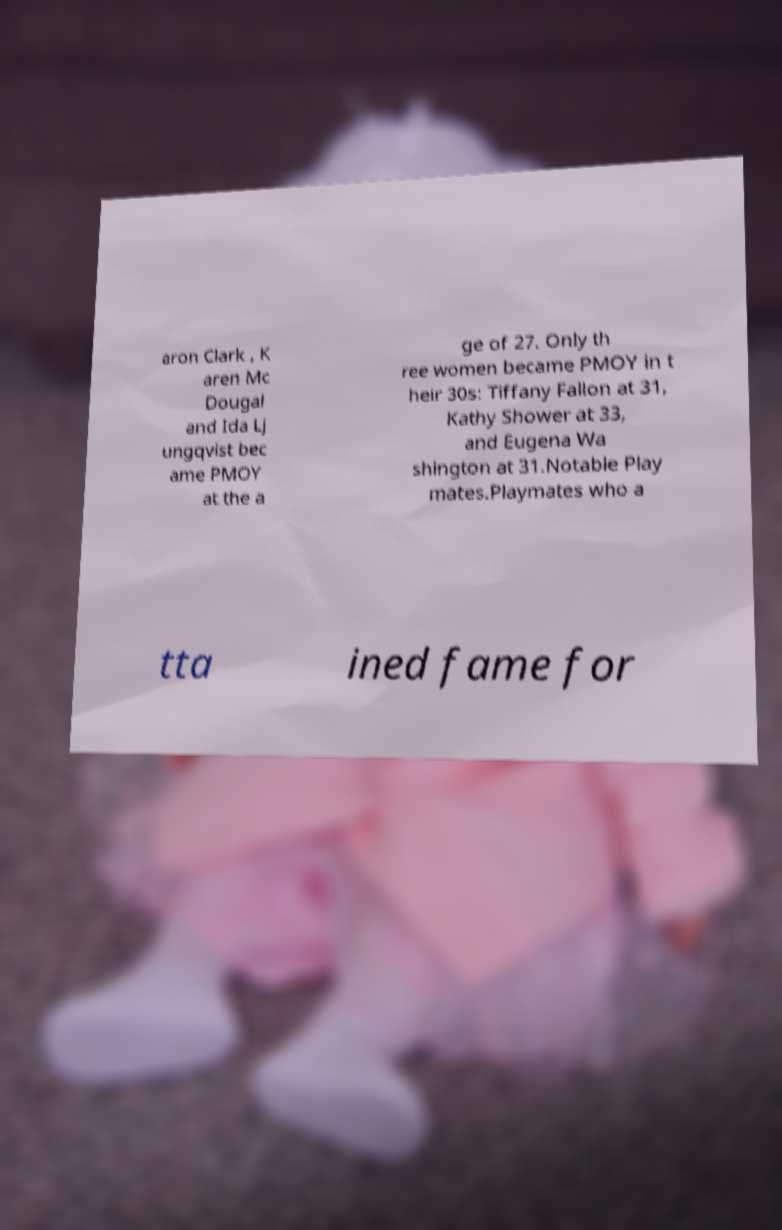Please read and relay the text visible in this image. What does it say? aron Clark , K aren Mc Dougal and Ida Lj ungqvist bec ame PMOY at the a ge of 27. Only th ree women became PMOY in t heir 30s: Tiffany Fallon at 31, Kathy Shower at 33, and Eugena Wa shington at 31.Notable Play mates.Playmates who a tta ined fame for 